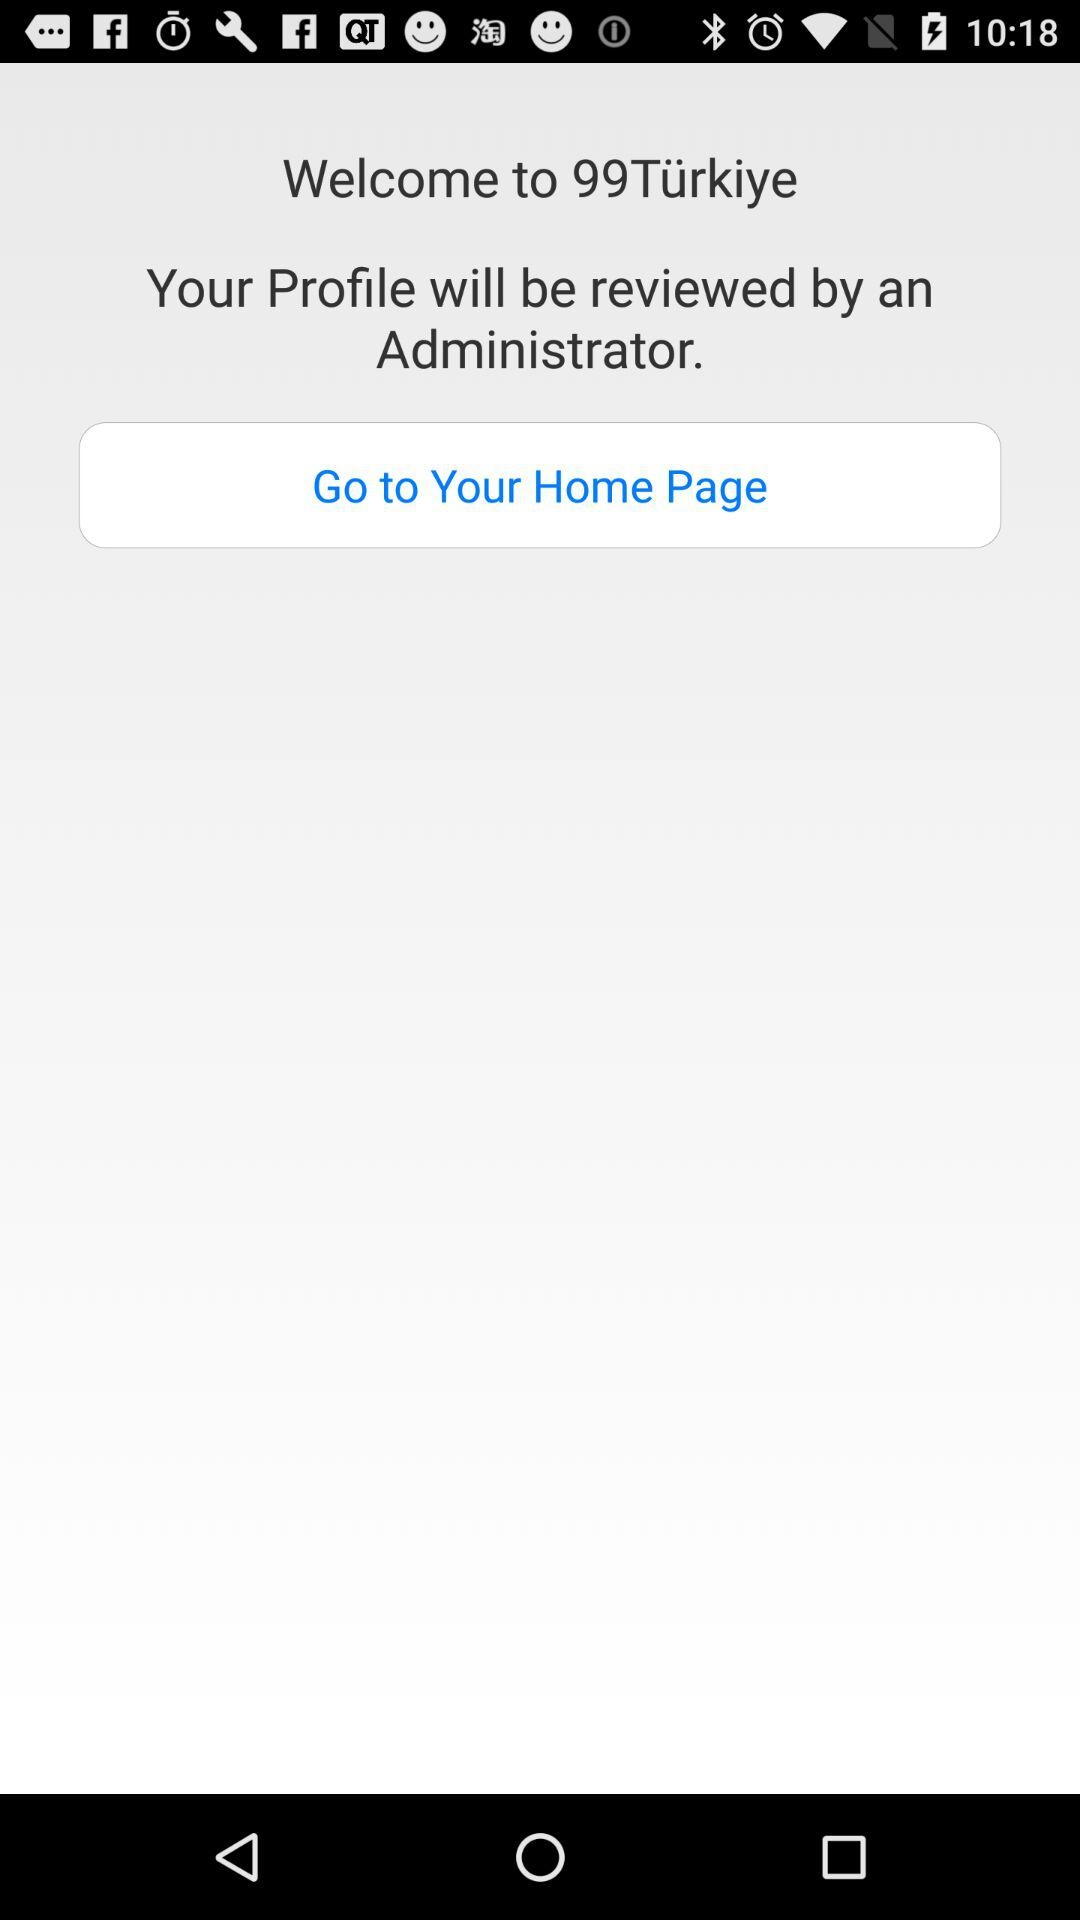What is the profile name?
When the provided information is insufficient, respond with <no answer>. <no answer> 